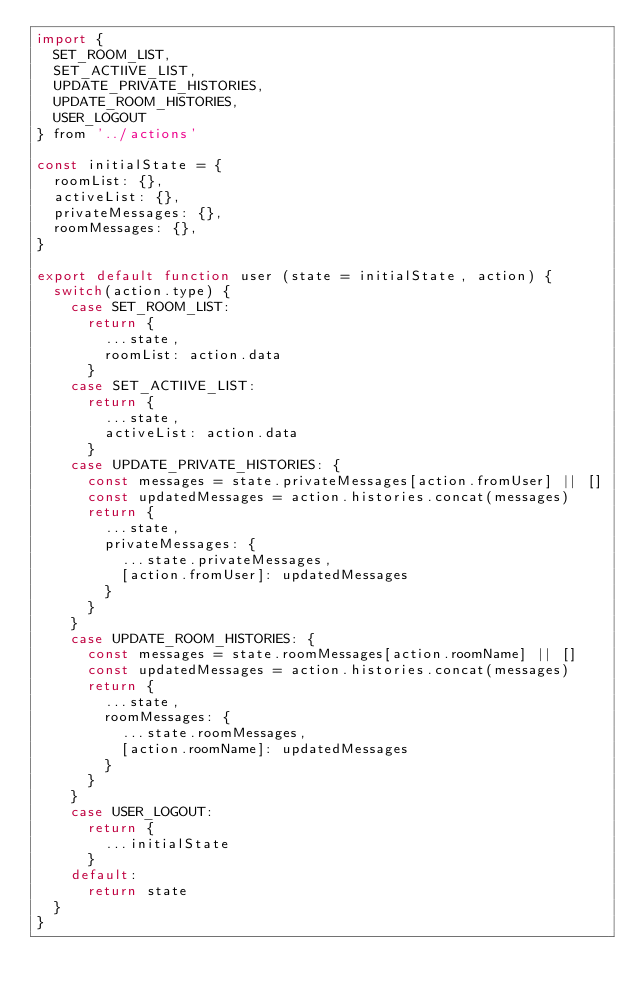Convert code to text. <code><loc_0><loc_0><loc_500><loc_500><_JavaScript_>import {
  SET_ROOM_LIST,
  SET_ACTIIVE_LIST,
  UPDATE_PRIVATE_HISTORIES,
  UPDATE_ROOM_HISTORIES,
  USER_LOGOUT
} from '../actions'

const initialState = {
  roomList: {},
  activeList: {},
  privateMessages: {},
  roomMessages: {},
}

export default function user (state = initialState, action) {
  switch(action.type) {
    case SET_ROOM_LIST:
      return {
        ...state,
        roomList: action.data
      }
    case SET_ACTIIVE_LIST:
      return {
        ...state,
        activeList: action.data
      }
    case UPDATE_PRIVATE_HISTORIES: {
      const messages = state.privateMessages[action.fromUser] || []
      const updatedMessages = action.histories.concat(messages)
      return {
        ...state,
        privateMessages: {
          ...state.privateMessages,
          [action.fromUser]: updatedMessages
        }
      }
    }
    case UPDATE_ROOM_HISTORIES: {
      const messages = state.roomMessages[action.roomName] || []
      const updatedMessages = action.histories.concat(messages)
      return {
        ...state,
        roomMessages: {
          ...state.roomMessages,
          [action.roomName]: updatedMessages
        }
      }
    }
    case USER_LOGOUT:
      return {
        ...initialState
      }
    default:
      return state
  }
}</code> 